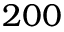<formula> <loc_0><loc_0><loc_500><loc_500>2 0 0</formula> 